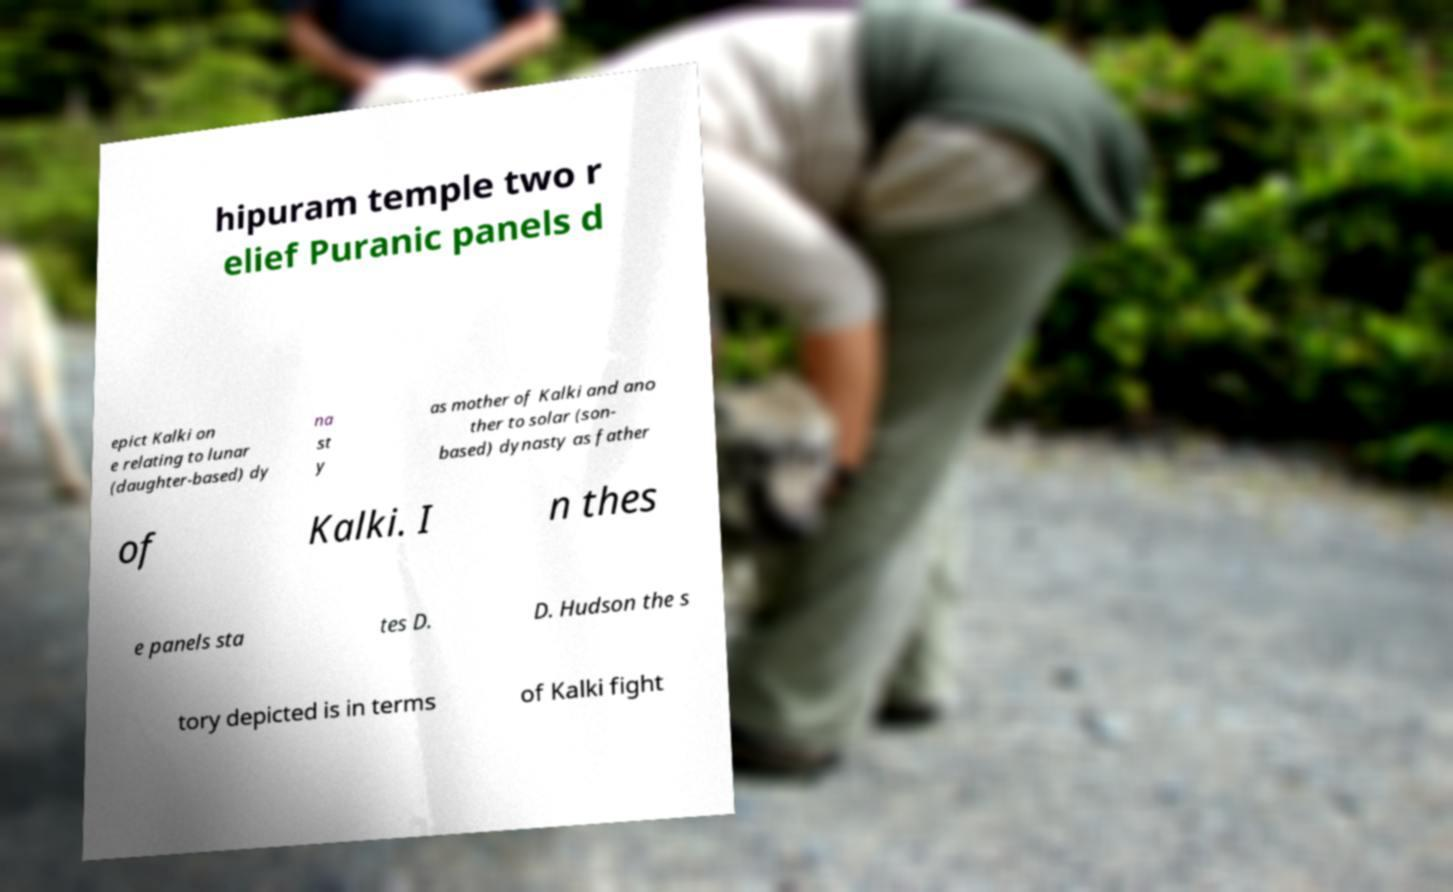For documentation purposes, I need the text within this image transcribed. Could you provide that? hipuram temple two r elief Puranic panels d epict Kalki on e relating to lunar (daughter-based) dy na st y as mother of Kalki and ano ther to solar (son- based) dynasty as father of Kalki. I n thes e panels sta tes D. D. Hudson the s tory depicted is in terms of Kalki fight 